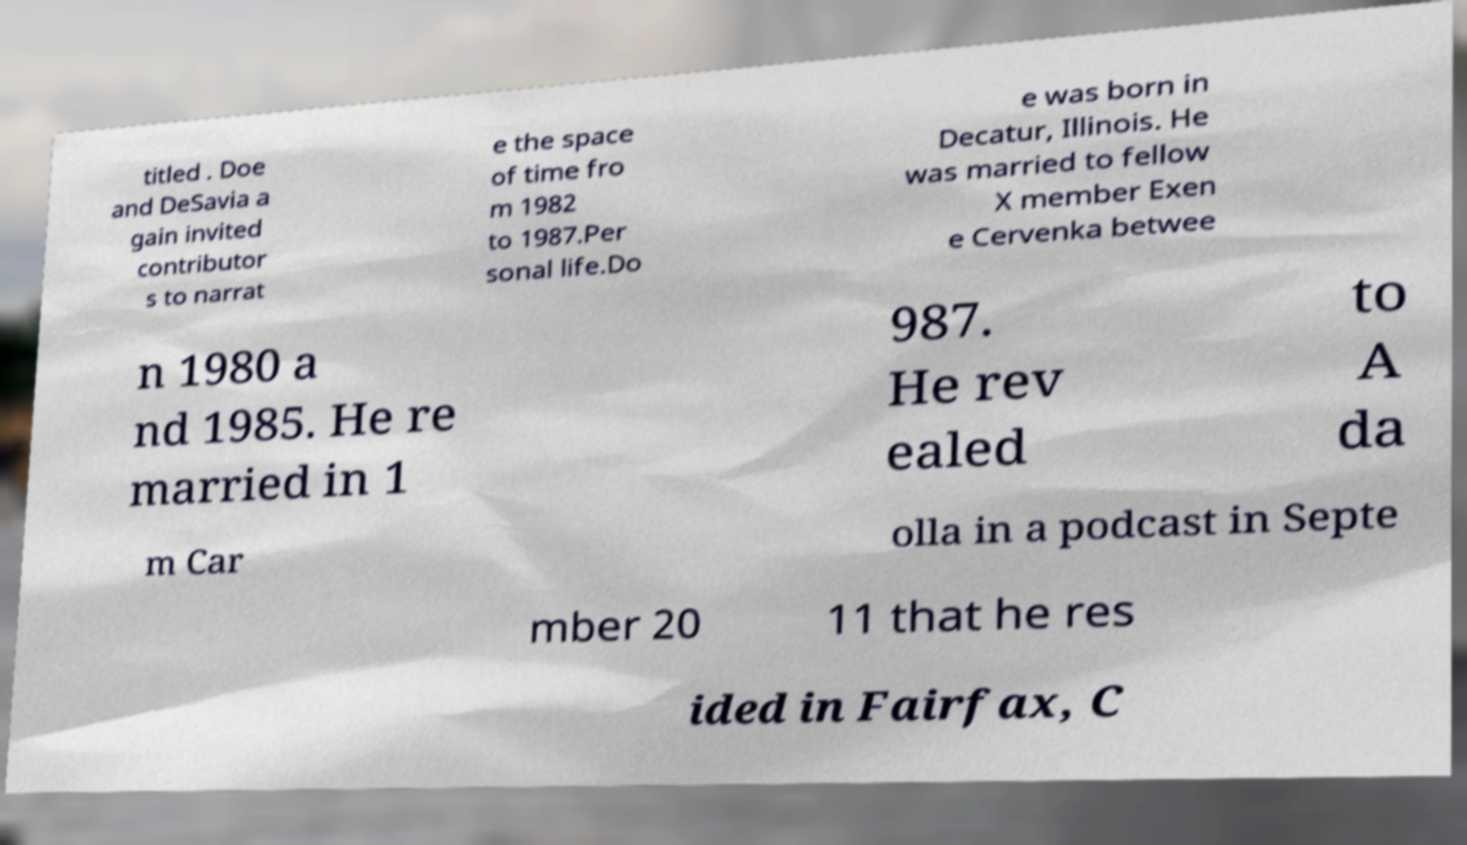I need the written content from this picture converted into text. Can you do that? titled . Doe and DeSavia a gain invited contributor s to narrat e the space of time fro m 1982 to 1987.Per sonal life.Do e was born in Decatur, Illinois. He was married to fellow X member Exen e Cervenka betwee n 1980 a nd 1985. He re married in 1 987. He rev ealed to A da m Car olla in a podcast in Septe mber 20 11 that he res ided in Fairfax, C 